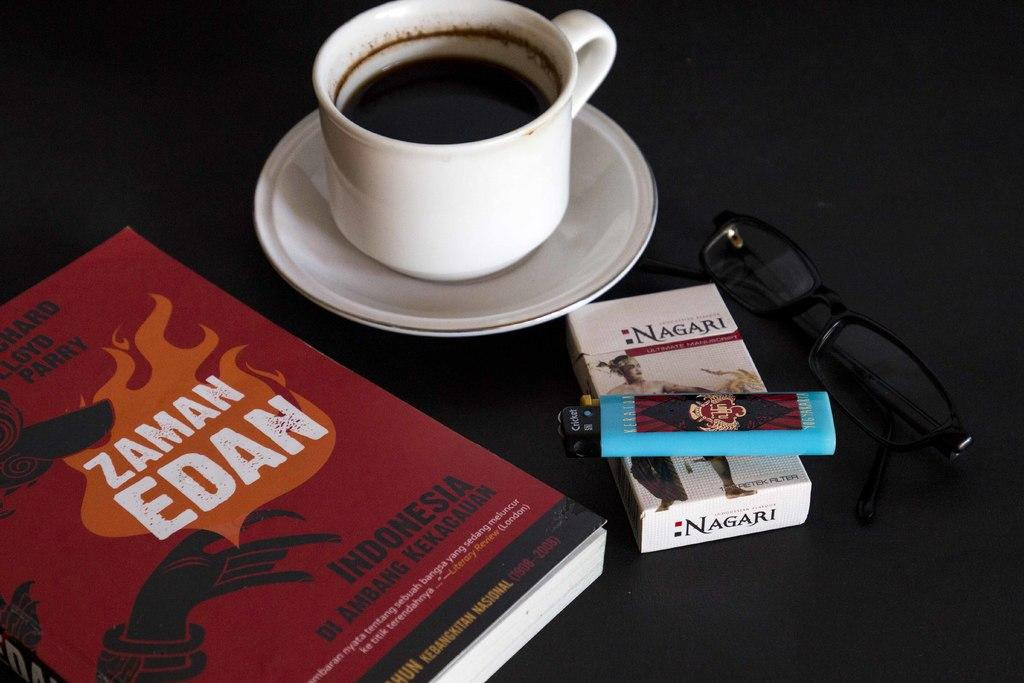Provide a one-sentence caption for the provided image. A cup of coffe sits on a table next to sunglasses, Nagari cigarettes , a lighter and a book by Zaman Edan. 